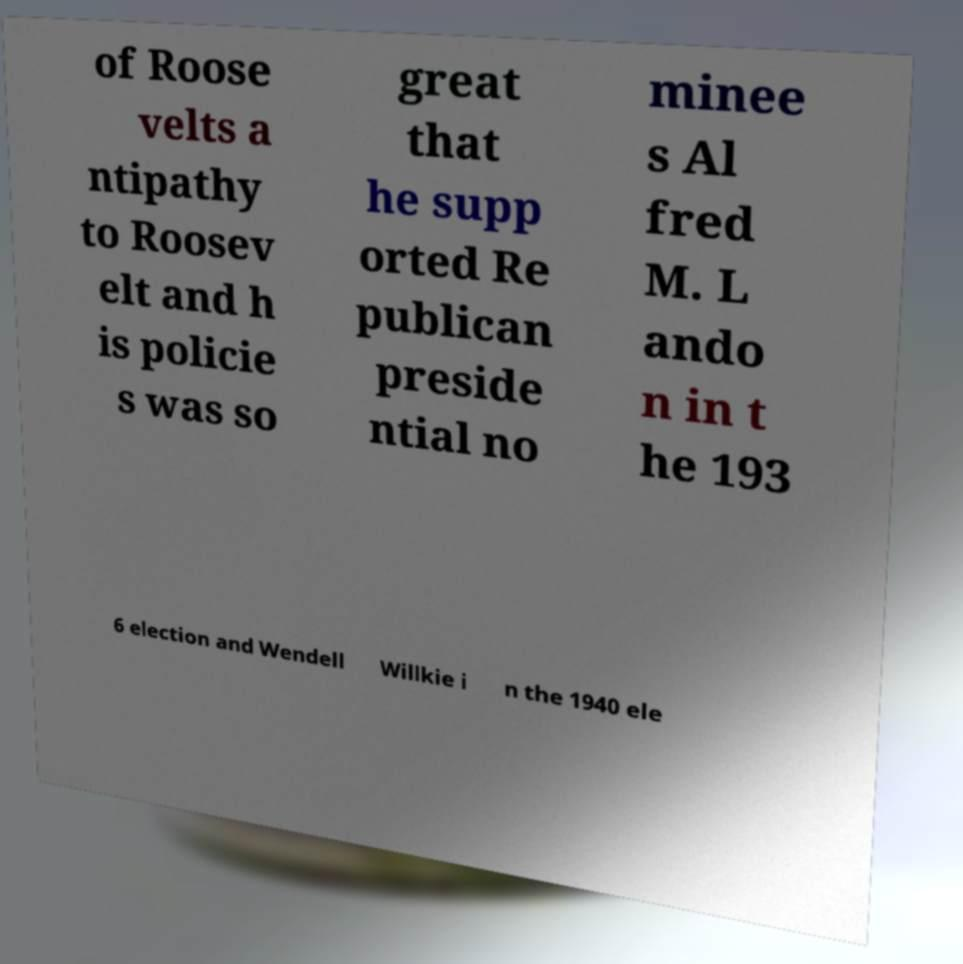Can you accurately transcribe the text from the provided image for me? of Roose velts a ntipathy to Roosev elt and h is policie s was so great that he supp orted Re publican preside ntial no minee s Al fred M. L ando n in t he 193 6 election and Wendell Willkie i n the 1940 ele 